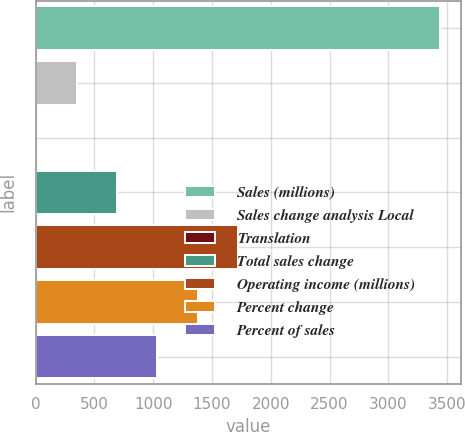Convert chart to OTSL. <chart><loc_0><loc_0><loc_500><loc_500><bar_chart><fcel>Sales (millions)<fcel>Sales change analysis Local<fcel>Translation<fcel>Total sales change<fcel>Operating income (millions)<fcel>Percent change<fcel>Percent of sales<nl><fcel>3444<fcel>348<fcel>4<fcel>692<fcel>1724<fcel>1380<fcel>1036<nl></chart> 